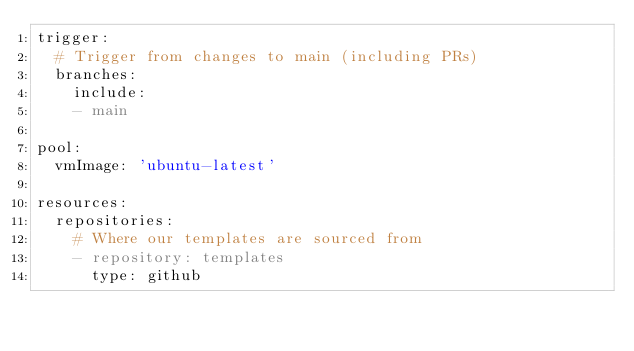<code> <loc_0><loc_0><loc_500><loc_500><_YAML_>trigger:
  # Trigger from changes to main (including PRs)
  branches:
    include:
    - main

pool:
  vmImage: 'ubuntu-latest'

resources:
  repositories:
    # Where our templates are sourced from
    - repository: templates
      type: github</code> 